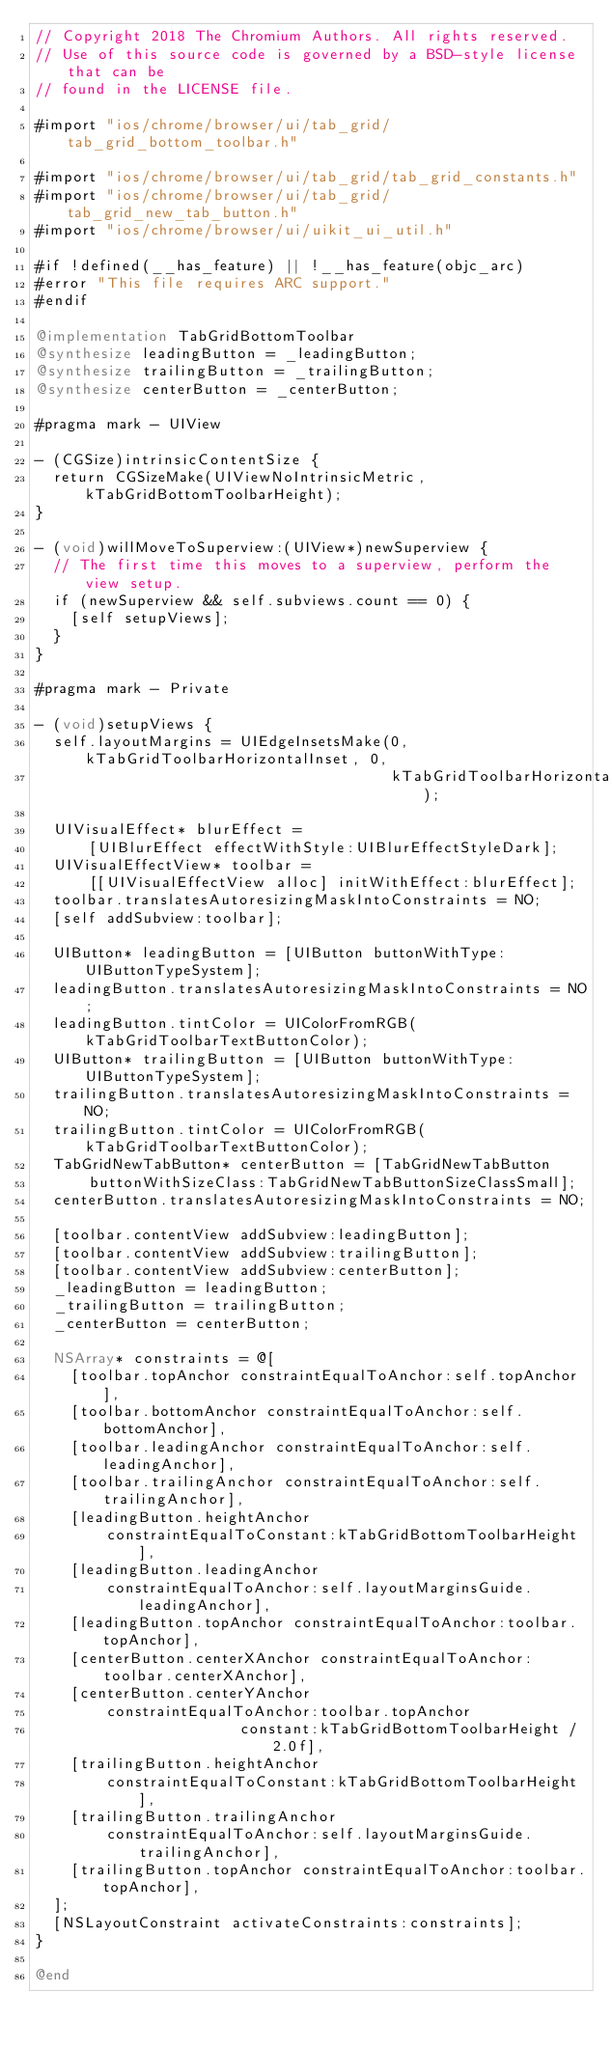Convert code to text. <code><loc_0><loc_0><loc_500><loc_500><_ObjectiveC_>// Copyright 2018 The Chromium Authors. All rights reserved.
// Use of this source code is governed by a BSD-style license that can be
// found in the LICENSE file.

#import "ios/chrome/browser/ui/tab_grid/tab_grid_bottom_toolbar.h"

#import "ios/chrome/browser/ui/tab_grid/tab_grid_constants.h"
#import "ios/chrome/browser/ui/tab_grid/tab_grid_new_tab_button.h"
#import "ios/chrome/browser/ui/uikit_ui_util.h"

#if !defined(__has_feature) || !__has_feature(objc_arc)
#error "This file requires ARC support."
#endif

@implementation TabGridBottomToolbar
@synthesize leadingButton = _leadingButton;
@synthesize trailingButton = _trailingButton;
@synthesize centerButton = _centerButton;

#pragma mark - UIView

- (CGSize)intrinsicContentSize {
  return CGSizeMake(UIViewNoIntrinsicMetric, kTabGridBottomToolbarHeight);
}

- (void)willMoveToSuperview:(UIView*)newSuperview {
  // The first time this moves to a superview, perform the view setup.
  if (newSuperview && self.subviews.count == 0) {
    [self setupViews];
  }
}

#pragma mark - Private

- (void)setupViews {
  self.layoutMargins = UIEdgeInsetsMake(0, kTabGridToolbarHorizontalInset, 0,
                                        kTabGridToolbarHorizontalInset);

  UIVisualEffect* blurEffect =
      [UIBlurEffect effectWithStyle:UIBlurEffectStyleDark];
  UIVisualEffectView* toolbar =
      [[UIVisualEffectView alloc] initWithEffect:blurEffect];
  toolbar.translatesAutoresizingMaskIntoConstraints = NO;
  [self addSubview:toolbar];

  UIButton* leadingButton = [UIButton buttonWithType:UIButtonTypeSystem];
  leadingButton.translatesAutoresizingMaskIntoConstraints = NO;
  leadingButton.tintColor = UIColorFromRGB(kTabGridToolbarTextButtonColor);
  UIButton* trailingButton = [UIButton buttonWithType:UIButtonTypeSystem];
  trailingButton.translatesAutoresizingMaskIntoConstraints = NO;
  trailingButton.tintColor = UIColorFromRGB(kTabGridToolbarTextButtonColor);
  TabGridNewTabButton* centerButton = [TabGridNewTabButton
      buttonWithSizeClass:TabGridNewTabButtonSizeClassSmall];
  centerButton.translatesAutoresizingMaskIntoConstraints = NO;

  [toolbar.contentView addSubview:leadingButton];
  [toolbar.contentView addSubview:trailingButton];
  [toolbar.contentView addSubview:centerButton];
  _leadingButton = leadingButton;
  _trailingButton = trailingButton;
  _centerButton = centerButton;

  NSArray* constraints = @[
    [toolbar.topAnchor constraintEqualToAnchor:self.topAnchor],
    [toolbar.bottomAnchor constraintEqualToAnchor:self.bottomAnchor],
    [toolbar.leadingAnchor constraintEqualToAnchor:self.leadingAnchor],
    [toolbar.trailingAnchor constraintEqualToAnchor:self.trailingAnchor],
    [leadingButton.heightAnchor
        constraintEqualToConstant:kTabGridBottomToolbarHeight],
    [leadingButton.leadingAnchor
        constraintEqualToAnchor:self.layoutMarginsGuide.leadingAnchor],
    [leadingButton.topAnchor constraintEqualToAnchor:toolbar.topAnchor],
    [centerButton.centerXAnchor constraintEqualToAnchor:toolbar.centerXAnchor],
    [centerButton.centerYAnchor
        constraintEqualToAnchor:toolbar.topAnchor
                       constant:kTabGridBottomToolbarHeight / 2.0f],
    [trailingButton.heightAnchor
        constraintEqualToConstant:kTabGridBottomToolbarHeight],
    [trailingButton.trailingAnchor
        constraintEqualToAnchor:self.layoutMarginsGuide.trailingAnchor],
    [trailingButton.topAnchor constraintEqualToAnchor:toolbar.topAnchor],
  ];
  [NSLayoutConstraint activateConstraints:constraints];
}

@end
</code> 